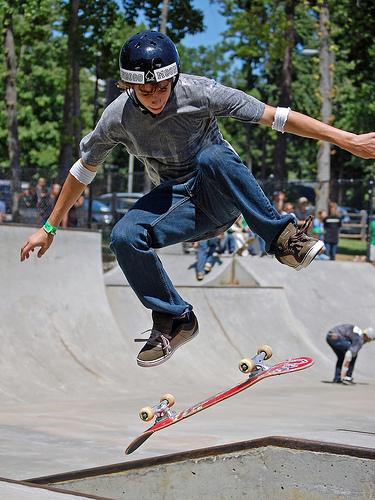Describe the young man and his outfit performing the action in the image. A young man in a black helmet, gray shirt, blue jeans, and brown shoes is executing a skateboard trick in mid-air. Talk about the main action, the person's outfit, and the skateboard's appearance. A young man in a gray shirt and blue jeans is executing a mid-air trick on a red skateboard with tan-colored wheels. Explain what the person in the image is doing and their appearance. A boy wearing a blue helmet, gray shirt, denim pants, and brown shoes is performing a trick on a skateboard with tan wheels. Describe the image in terms of the young man's outfit and the location. In a skate park with clear skies and trees, a young man in a gray shirt and denim pants performs an impressive skateboarding trick. Explain the image highlighting the boy's protective gear and skateboard. A boy is wearing a dark blue helmet with white trim and protective bands while doing a trick on a red skateboard with tan wheels. Narrate the scene focusing on the skateboard and the person's attire. A boy wearing a blue helmet, gray t-shirt, and denim pants is using a red skateboard with tan wheels to perform a trick. Mention the main subject, action, and important details in the image. A boy wearing a helmet and protective bands performs a skateboard trick in a skate park with tall trees in the background. Describe the action occurring in the image and the object being used. A boy is performing a skateboard trick mid-air, using a red skateboard with tan-colored wheels. Briefly mention the key elements and action in the image. A young man wearing a black helmet and gray shirt is doing a trick on a red skateboard in a skate park. Focus on the boy's helmet and wristband while describing the image. The boy is wearing a dark blue helmet with a spade design and a green wristband as he does a trick on a red skateboard. 